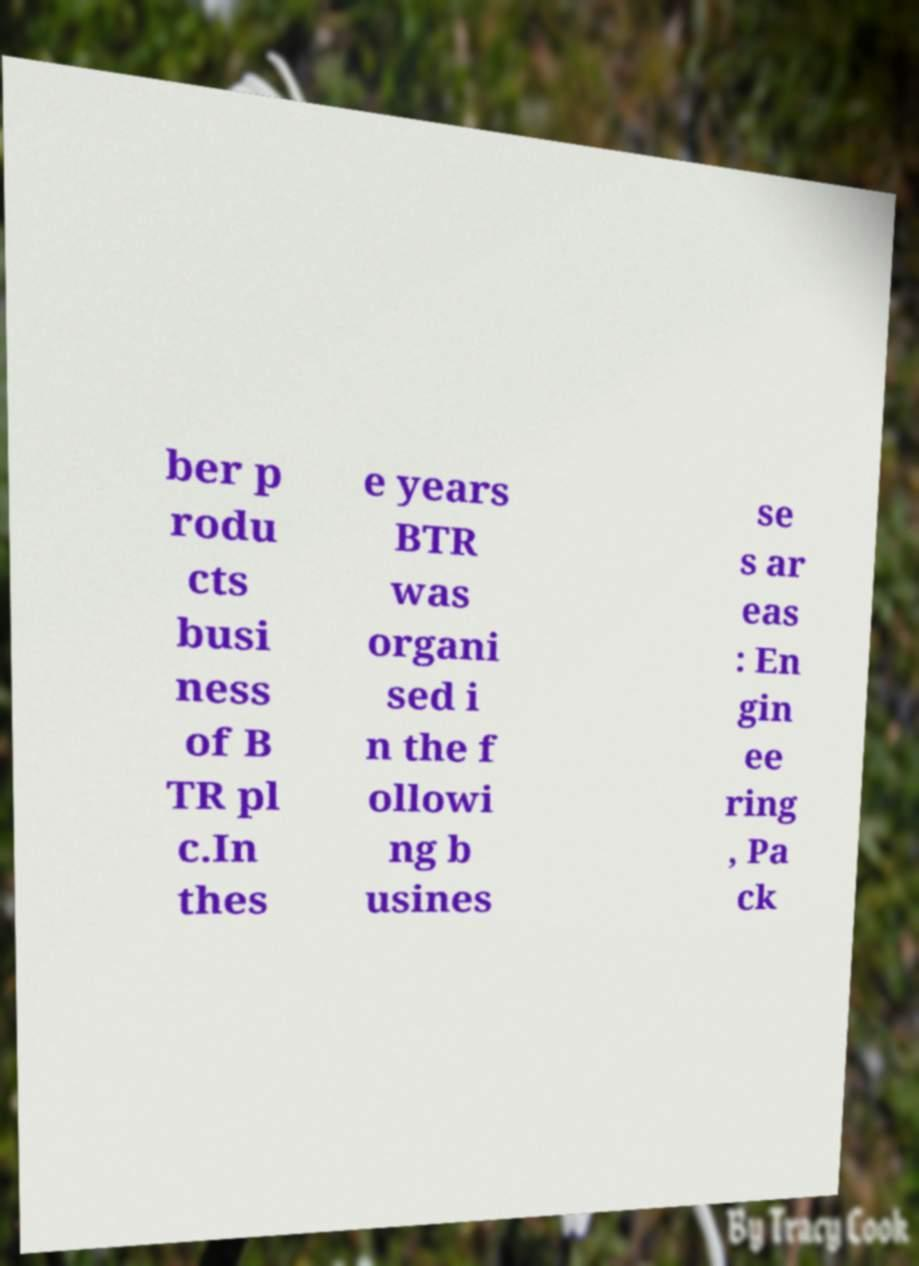Could you assist in decoding the text presented in this image and type it out clearly? ber p rodu cts busi ness of B TR pl c.In thes e years BTR was organi sed i n the f ollowi ng b usines se s ar eas : En gin ee ring , Pa ck 